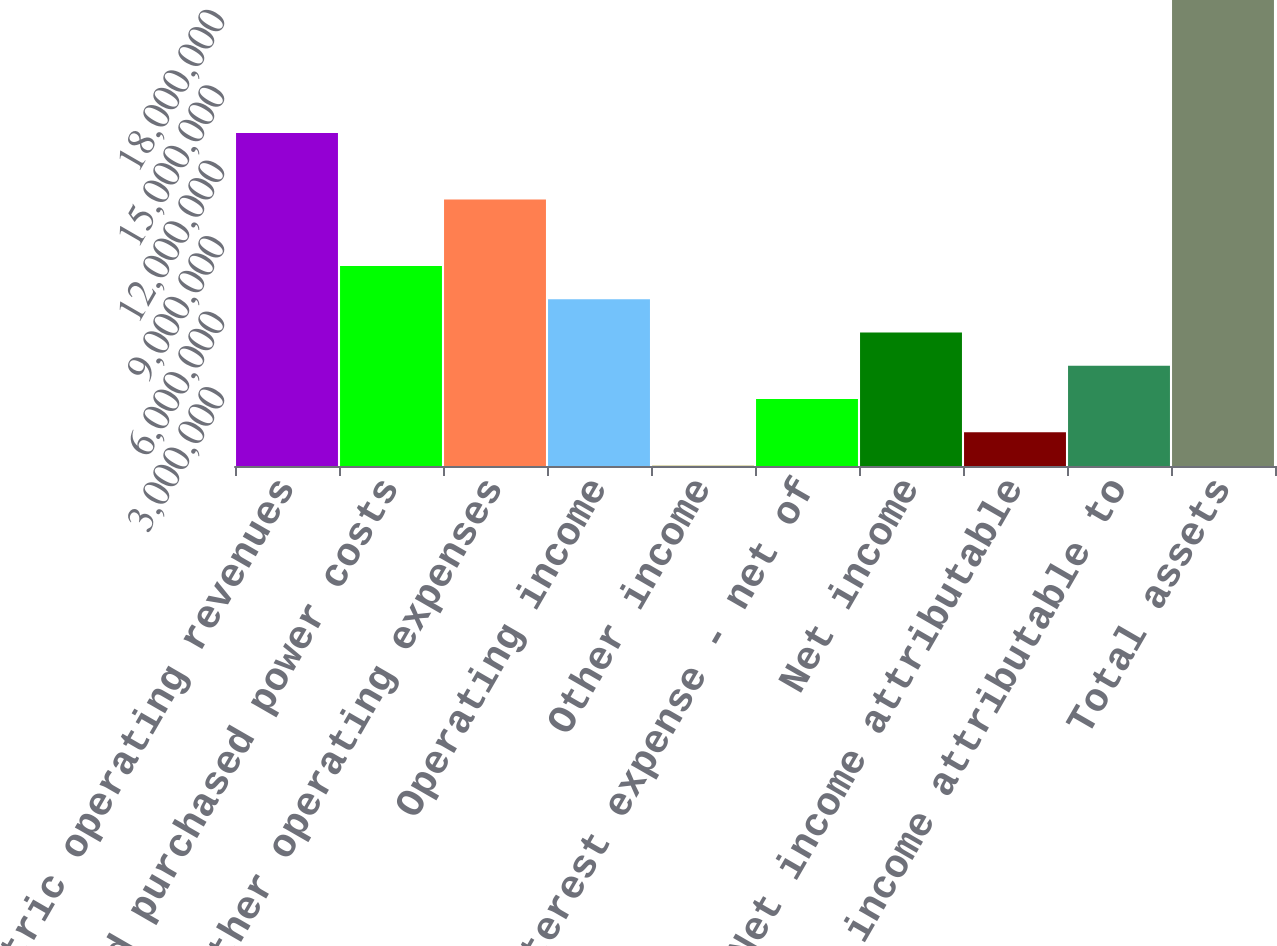Convert chart. <chart><loc_0><loc_0><loc_500><loc_500><bar_chart><fcel>Electric operating revenues<fcel>Fuel and purchased power costs<fcel>Other operating expenses<fcel>Operating income<fcel>Other income<fcel>Interest expense - net of<fcel>Net income<fcel>Less Net income attributable<fcel>Net income attributable to<fcel>Total assets<nl><fcel>1.32425e+07<fcel>7.95207e+06<fcel>1.05973e+07<fcel>6.62945e+06<fcel>16358<fcel>2.66159e+06<fcel>5.30683e+06<fcel>1.33898e+06<fcel>3.98421e+06<fcel>1.8533e+07<nl></chart> 